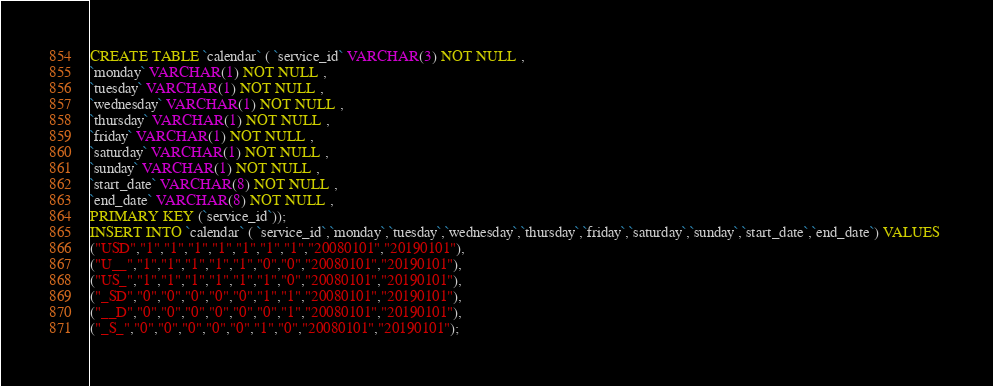Convert code to text. <code><loc_0><loc_0><loc_500><loc_500><_SQL_>CREATE TABLE `calendar` ( `service_id` VARCHAR(3) NOT NULL ,
`monday` VARCHAR(1) NOT NULL ,
`tuesday` VARCHAR(1) NOT NULL ,
`wednesday` VARCHAR(1) NOT NULL ,
`thursday` VARCHAR(1) NOT NULL ,
`friday` VARCHAR(1) NOT NULL ,
`saturday` VARCHAR(1) NOT NULL ,
`sunday` VARCHAR(1) NOT NULL ,
`start_date` VARCHAR(8) NOT NULL ,
`end_date` VARCHAR(8) NOT NULL ,
PRIMARY KEY (`service_id`));
INSERT INTO `calendar` ( `service_id`,`monday`,`tuesday`,`wednesday`,`thursday`,`friday`,`saturday`,`sunday`,`start_date`,`end_date`) VALUES 
("USD","1","1","1","1","1","1","1","20080101","20190101"),
("U__","1","1","1","1","1","0","0","20080101","20190101"),
("US_","1","1","1","1","1","1","0","20080101","20190101"),
("_SD","0","0","0","0","0","1","1","20080101","20190101"),
("__D","0","0","0","0","0","0","1","20080101","20190101"),
("_S_","0","0","0","0","0","1","0","20080101","20190101");</code> 